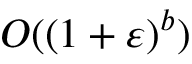<formula> <loc_0><loc_0><loc_500><loc_500>O ( ( 1 + \varepsilon ) ^ { b } )</formula> 